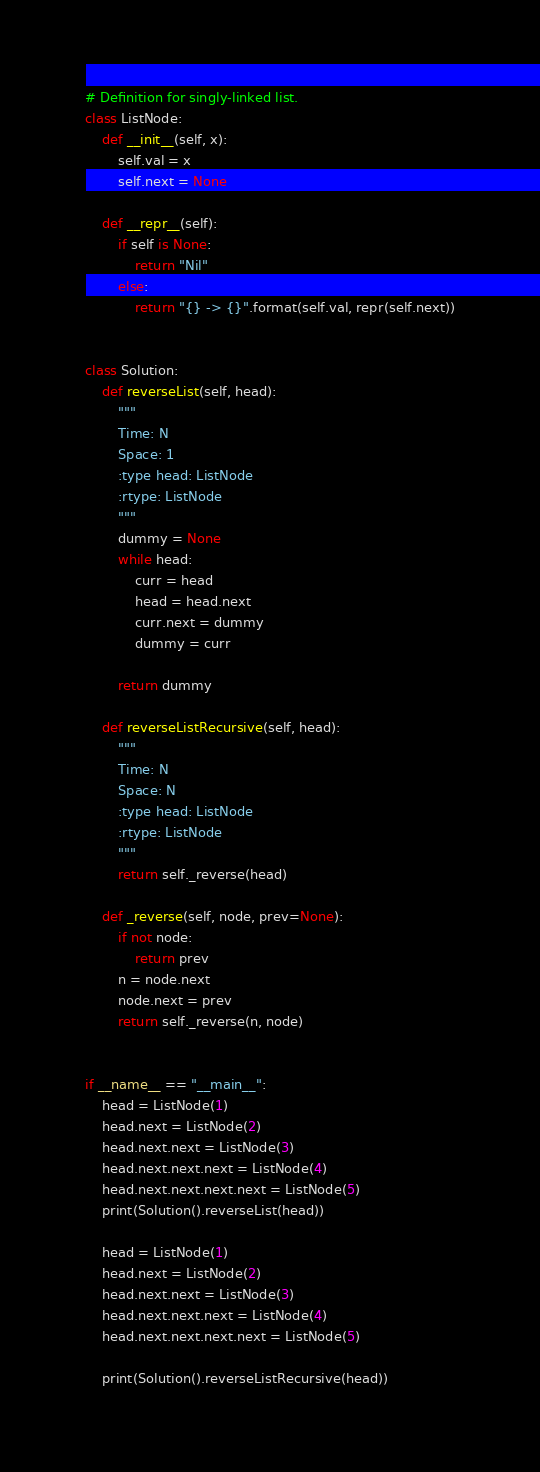<code> <loc_0><loc_0><loc_500><loc_500><_Python_># Definition for singly-linked list.
class ListNode:
    def __init__(self, x):
        self.val = x
        self.next = None

    def __repr__(self):
        if self is None:
            return "Nil"
        else:
            return "{} -> {}".format(self.val, repr(self.next))


class Solution:
    def reverseList(self, head):
        """
        Time: N
        Space: 1
        :type head: ListNode
        :rtype: ListNode
        """
        dummy = None
        while head:
            curr = head
            head = head.next
            curr.next = dummy
            dummy = curr

        return dummy

    def reverseListRecursive(self, head):
        """
        Time: N
        Space: N
        :type head: ListNode
        :rtype: ListNode
        """
        return self._reverse(head)

    def _reverse(self, node, prev=None):
        if not node:
            return prev
        n = node.next
        node.next = prev
        return self._reverse(n, node)


if __name__ == "__main__":
    head = ListNode(1)
    head.next = ListNode(2)
    head.next.next = ListNode(3)
    head.next.next.next = ListNode(4)
    head.next.next.next.next = ListNode(5)
    print(Solution().reverseList(head))

    head = ListNode(1)
    head.next = ListNode(2)
    head.next.next = ListNode(3)
    head.next.next.next = ListNode(4)
    head.next.next.next.next = ListNode(5)

    print(Solution().reverseListRecursive(head))
</code> 